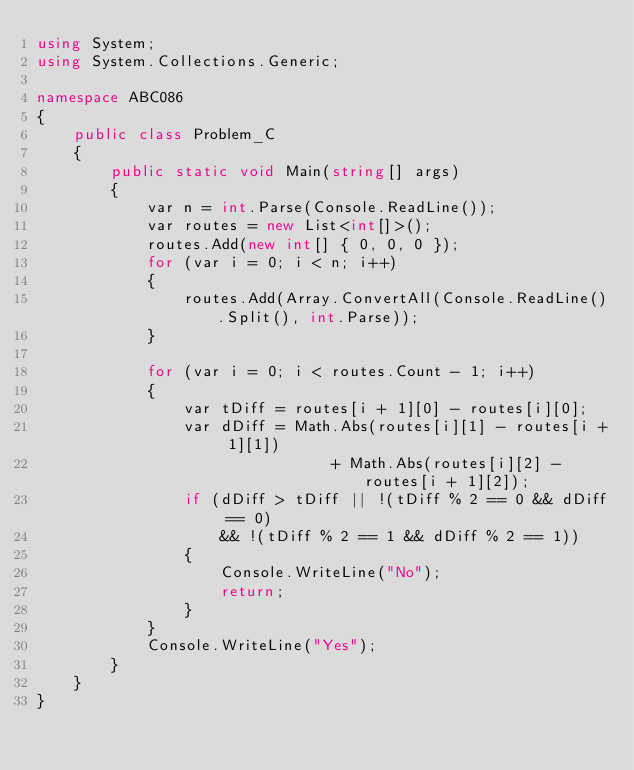<code> <loc_0><loc_0><loc_500><loc_500><_C#_>using System;
using System.Collections.Generic;

namespace ABC086
{
    public class Problem_C
    {
        public static void Main(string[] args)
        {
            var n = int.Parse(Console.ReadLine());
            var routes = new List<int[]>();
            routes.Add(new int[] { 0, 0, 0 });
            for (var i = 0; i < n; i++)
            {
                routes.Add(Array.ConvertAll(Console.ReadLine().Split(), int.Parse));
            }

            for (var i = 0; i < routes.Count - 1; i++)
            {
                var tDiff = routes[i + 1][0] - routes[i][0];
                var dDiff = Math.Abs(routes[i][1] - routes[i + 1][1])
                                + Math.Abs(routes[i][2] - routes[i + 1][2]);
                if (dDiff > tDiff || !(tDiff % 2 == 0 && dDiff == 0)
                    && !(tDiff % 2 == 1 && dDiff % 2 == 1))
                {
                    Console.WriteLine("No");
                    return;
                }
            }
            Console.WriteLine("Yes");
        }
    }
}
</code> 